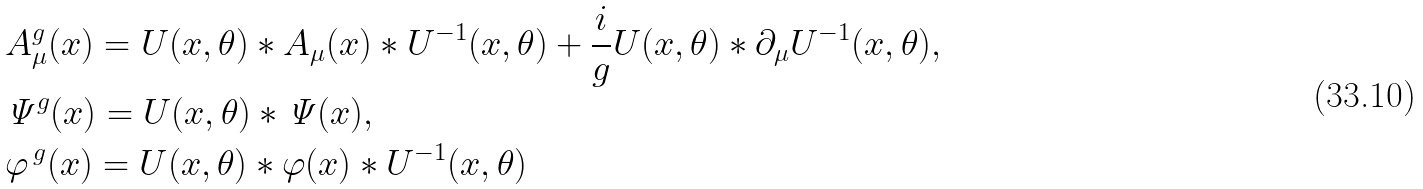Convert formula to latex. <formula><loc_0><loc_0><loc_500><loc_500>& A ^ { g } _ { \mu } ( x ) = U ( x , \theta ) \ast A _ { \mu } ( x ) \ast U ^ { - 1 } ( x , \theta ) + \frac { i } { g } U ( x , \theta ) \ast \partial _ { \mu } U ^ { - 1 } ( x , \theta ) , \\ & { \mathit \Psi } ^ { g } ( x ) = U ( x , \theta ) \ast { \mathit \Psi } ( x ) , \\ & \varphi ^ { \, g } ( x ) = U ( x , \theta ) \ast \varphi ( x ) \ast U ^ { - 1 } ( x , \theta )</formula> 